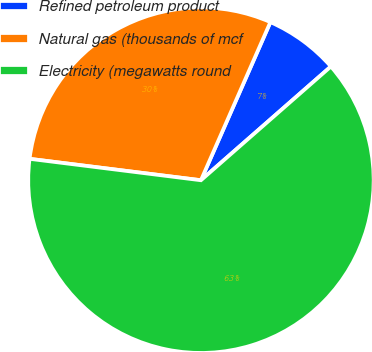Convert chart to OTSL. <chart><loc_0><loc_0><loc_500><loc_500><pie_chart><fcel>Refined petroleum product<fcel>Natural gas (thousands of mcf<fcel>Electricity (megawatts round<nl><fcel>6.97%<fcel>29.61%<fcel>63.43%<nl></chart> 